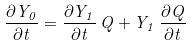<formula> <loc_0><loc_0><loc_500><loc_500>\frac { \partial Y _ { 0 } } { \partial t } = \frac { \partial Y _ { 1 } } { \partial t } \, Q + Y _ { 1 } \, \frac { \partial Q } { \partial t }</formula> 